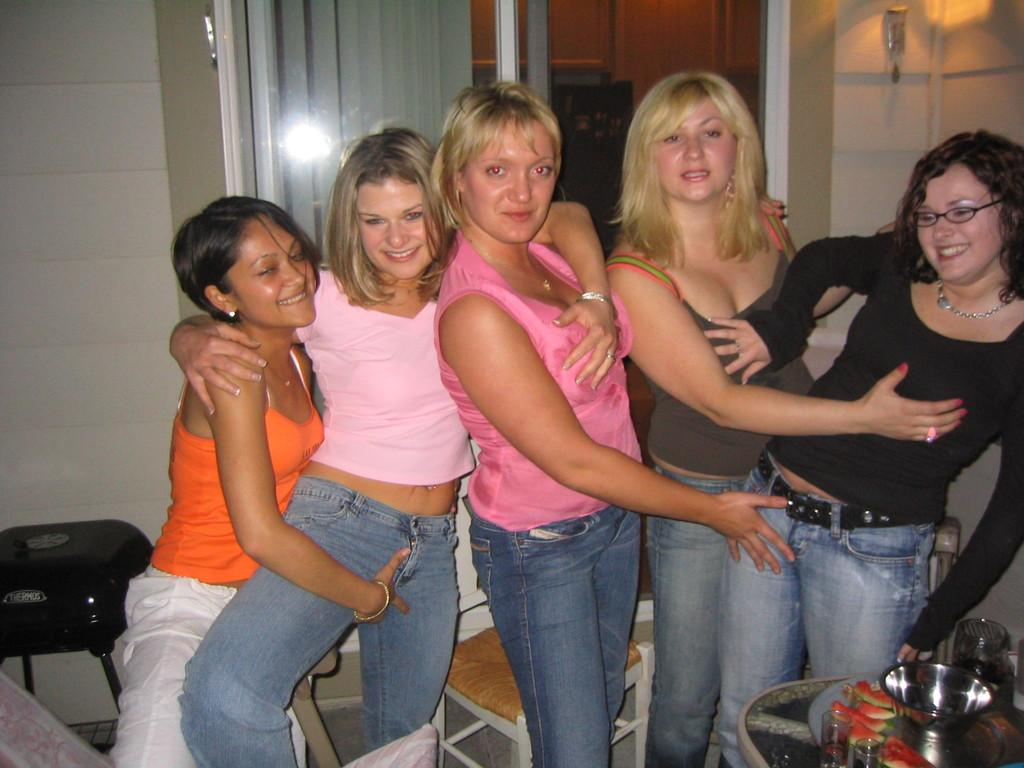Who is present in the image? There are women standing in the image. What can be seen on the right side of the image? There is a table on the right side of the image. What is on the table? There are utensils on the table. What is visible in the background of the image? There is a wall and a door in the background of the image. What type of hen can be seen sleeping on the table in the image? There is no hen present in the image, and no one is sleeping on the table. 